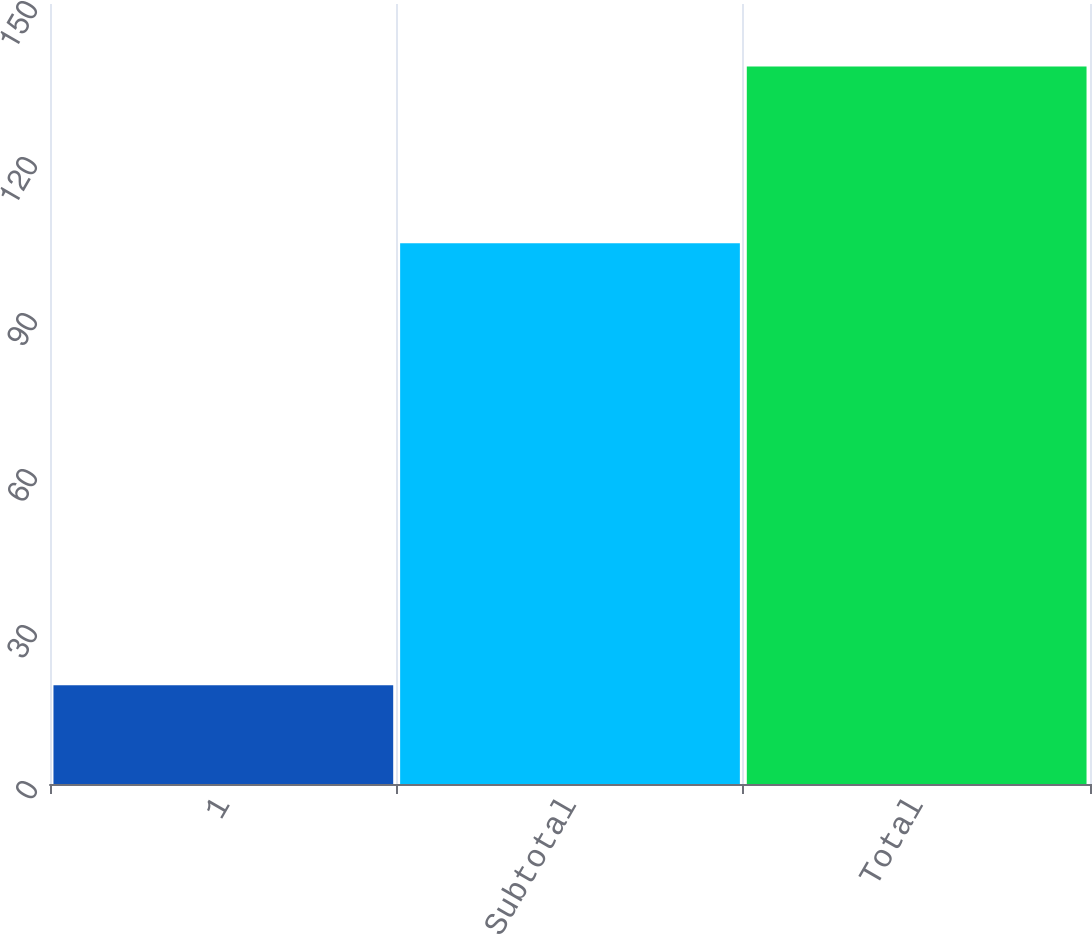<chart> <loc_0><loc_0><loc_500><loc_500><bar_chart><fcel>1<fcel>Subtotal<fcel>Total<nl><fcel>19<fcel>104<fcel>138<nl></chart> 